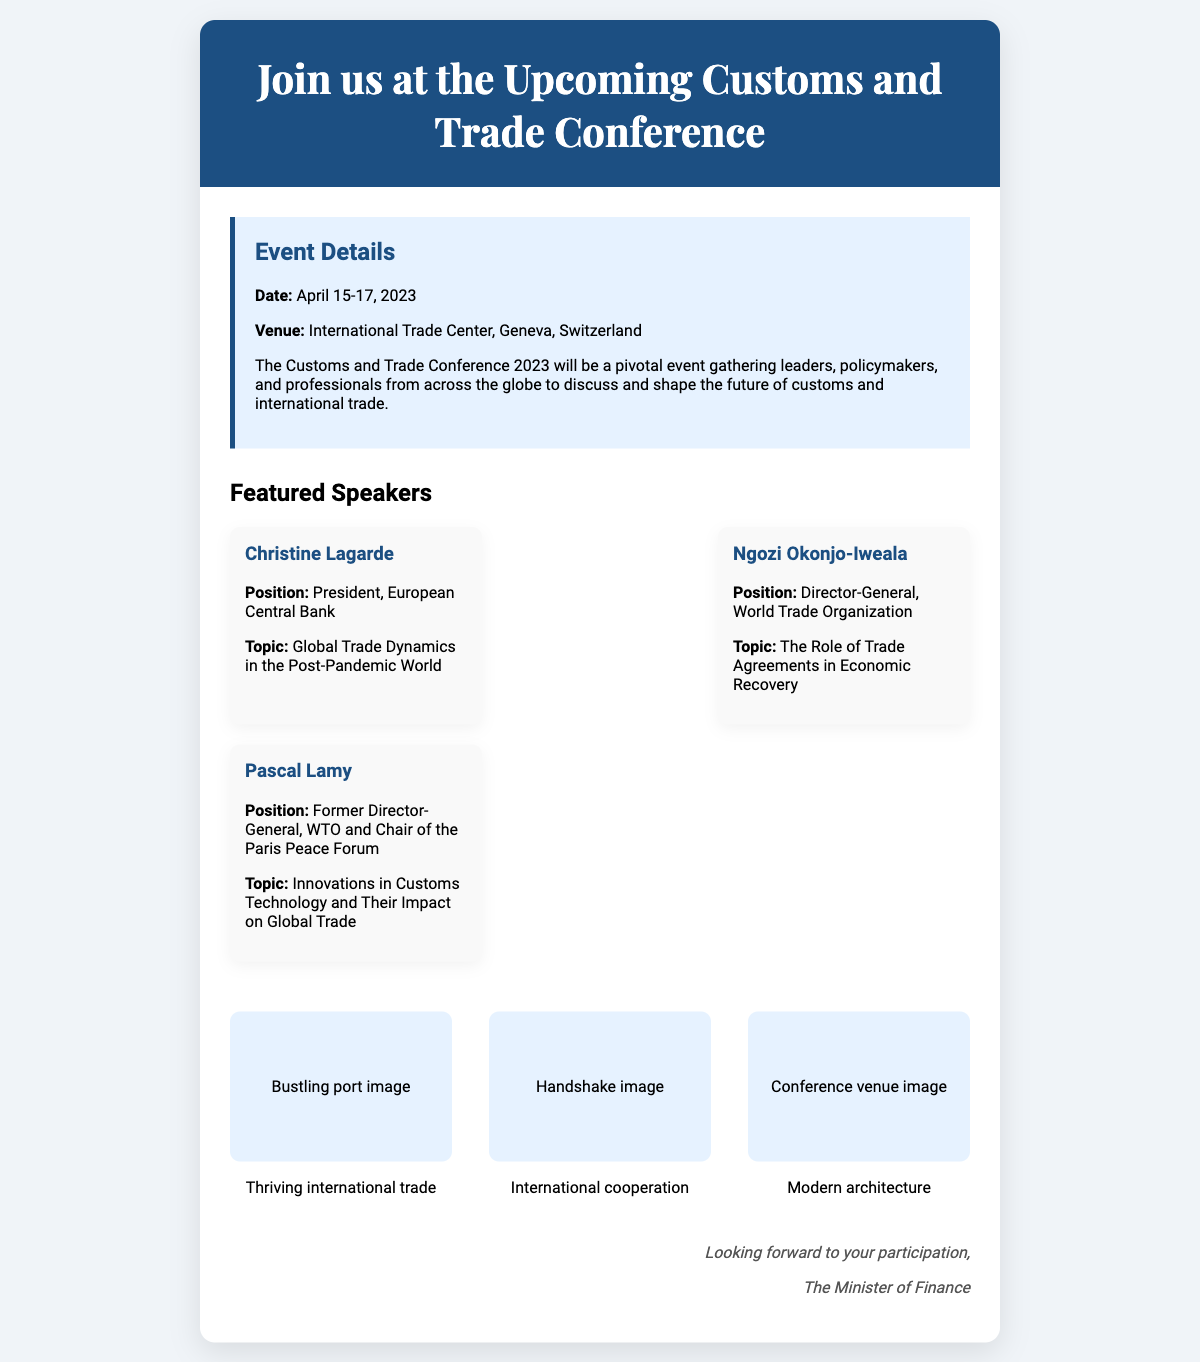What are the dates of the conference? The dates of the conference are explicitly mentioned in the document.
Answer: April 15-17, 2023 Where is the conference held? The venue of the conference is stated clearly in the document.
Answer: International Trade Center, Geneva, Switzerland Who is the first featured speaker? The document lists the featured speakers, and the first one is specified.
Answer: Christine Lagarde What topic will Christine Lagarde speak about? The document provides the topic for each speaker, including Christine Lagarde.
Answer: Global Trade Dynamics in the Post-Pandemic World How many featured speakers are mentioned? The document lists the number of speakers featured in the conference.
Answer: Three What is the background color of the header? The document describes the UI elements, including the header's background.
Answer: #1c4f82 What type of event is this document promoting? The document highlights the nature of the event being promoted.
Answer: Conference What kind of imagery is included in the document? The document describes the types of imagery included alongside the text.
Answer: Motivational imagery What is the speaker’s position of Ngozi Okonjo-Iweala? The document specifies the position of each speaker featured.
Answer: Director-General, World Trade Organization 